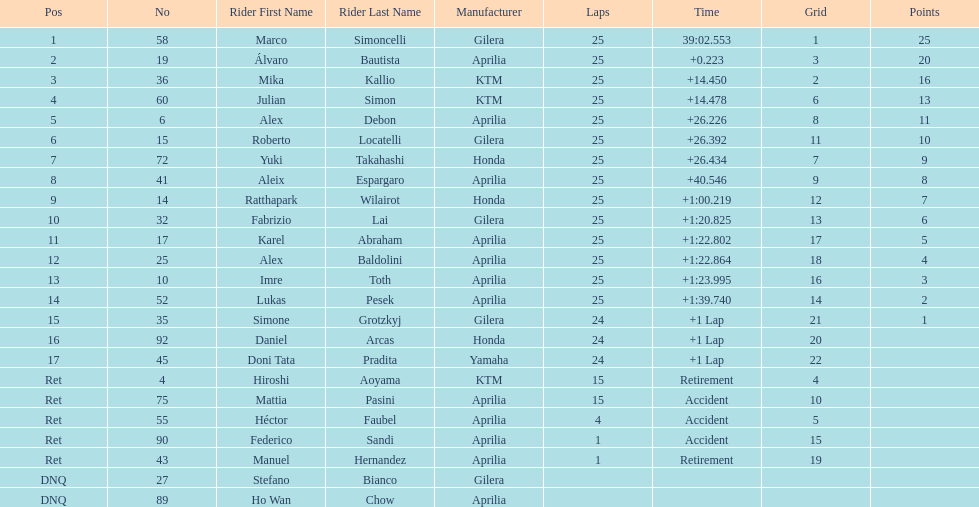Could you help me parse every detail presented in this table? {'header': ['Pos', 'No', 'Rider First Name', 'Rider Last Name', 'Manufacturer', 'Laps', 'Time', 'Grid', 'Points'], 'rows': [['1', '58', 'Marco', 'Simoncelli', 'Gilera', '25', '39:02.553', '1', '25'], ['2', '19', 'Álvaro', 'Bautista', 'Aprilia', '25', '+0.223', '3', '20'], ['3', '36', 'Mika', 'Kallio', 'KTM', '25', '+14.450', '2', '16'], ['4', '60', 'Julian', 'Simon', 'KTM', '25', '+14.478', '6', '13'], ['5', '6', 'Alex', 'Debon', 'Aprilia', '25', '+26.226', '8', '11'], ['6', '15', 'Roberto', 'Locatelli', 'Gilera', '25', '+26.392', '11', '10'], ['7', '72', 'Yuki', 'Takahashi', 'Honda', '25', '+26.434', '7', '9'], ['8', '41', 'Aleix', 'Espargaro', 'Aprilia', '25', '+40.546', '9', '8'], ['9', '14', 'Ratthapark', 'Wilairot', 'Honda', '25', '+1:00.219', '12', '7'], ['10', '32', 'Fabrizio', 'Lai', 'Gilera', '25', '+1:20.825', '13', '6'], ['11', '17', 'Karel', 'Abraham', 'Aprilia', '25', '+1:22.802', '17', '5'], ['12', '25', 'Alex', 'Baldolini', 'Aprilia', '25', '+1:22.864', '18', '4'], ['13', '10', 'Imre', 'Toth', 'Aprilia', '25', '+1:23.995', '16', '3'], ['14', '52', 'Lukas', 'Pesek', 'Aprilia', '25', '+1:39.740', '14', '2'], ['15', '35', 'Simone', 'Grotzkyj', 'Gilera', '24', '+1 Lap', '21', '1'], ['16', '92', 'Daniel', 'Arcas', 'Honda', '24', '+1 Lap', '20', ''], ['17', '45', 'Doni Tata', 'Pradita', 'Yamaha', '24', '+1 Lap', '22', ''], ['Ret', '4', 'Hiroshi', 'Aoyama', 'KTM', '15', 'Retirement', '4', ''], ['Ret', '75', 'Mattia', 'Pasini', 'Aprilia', '15', 'Accident', '10', ''], ['Ret', '55', 'Héctor', 'Faubel', 'Aprilia', '4', 'Accident', '5', ''], ['Ret', '90', 'Federico', 'Sandi', 'Aprilia', '1', 'Accident', '15', ''], ['Ret', '43', 'Manuel', 'Hernandez', 'Aprilia', '1', 'Retirement', '19', ''], ['DNQ', '27', 'Stefano', 'Bianco', 'Gilera', '', '', '', ''], ['DNQ', '89', 'Ho Wan', 'Chow', 'Aprilia', '', '', '', '']]} What is the total number of laps performed by rider imre toth? 25. 